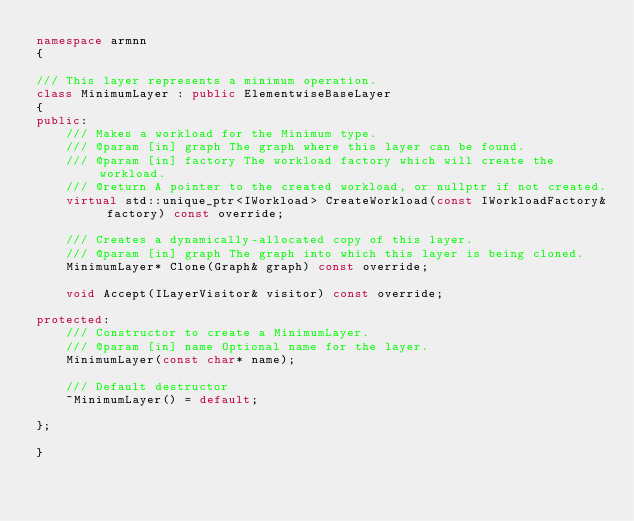Convert code to text. <code><loc_0><loc_0><loc_500><loc_500><_C++_>namespace armnn
{

/// This layer represents a minimum operation.
class MinimumLayer : public ElementwiseBaseLayer
{
public:
    /// Makes a workload for the Minimum type.
    /// @param [in] graph The graph where this layer can be found.
    /// @param [in] factory The workload factory which will create the workload.
    /// @return A pointer to the created workload, or nullptr if not created.
    virtual std::unique_ptr<IWorkload> CreateWorkload(const IWorkloadFactory& factory) const override;

    /// Creates a dynamically-allocated copy of this layer.
    /// @param [in] graph The graph into which this layer is being cloned.
    MinimumLayer* Clone(Graph& graph) const override;

    void Accept(ILayerVisitor& visitor) const override;

protected:
    /// Constructor to create a MinimumLayer.
    /// @param [in] name Optional name for the layer.
    MinimumLayer(const char* name);

    /// Default destructor
    ~MinimumLayer() = default;

};

}</code> 